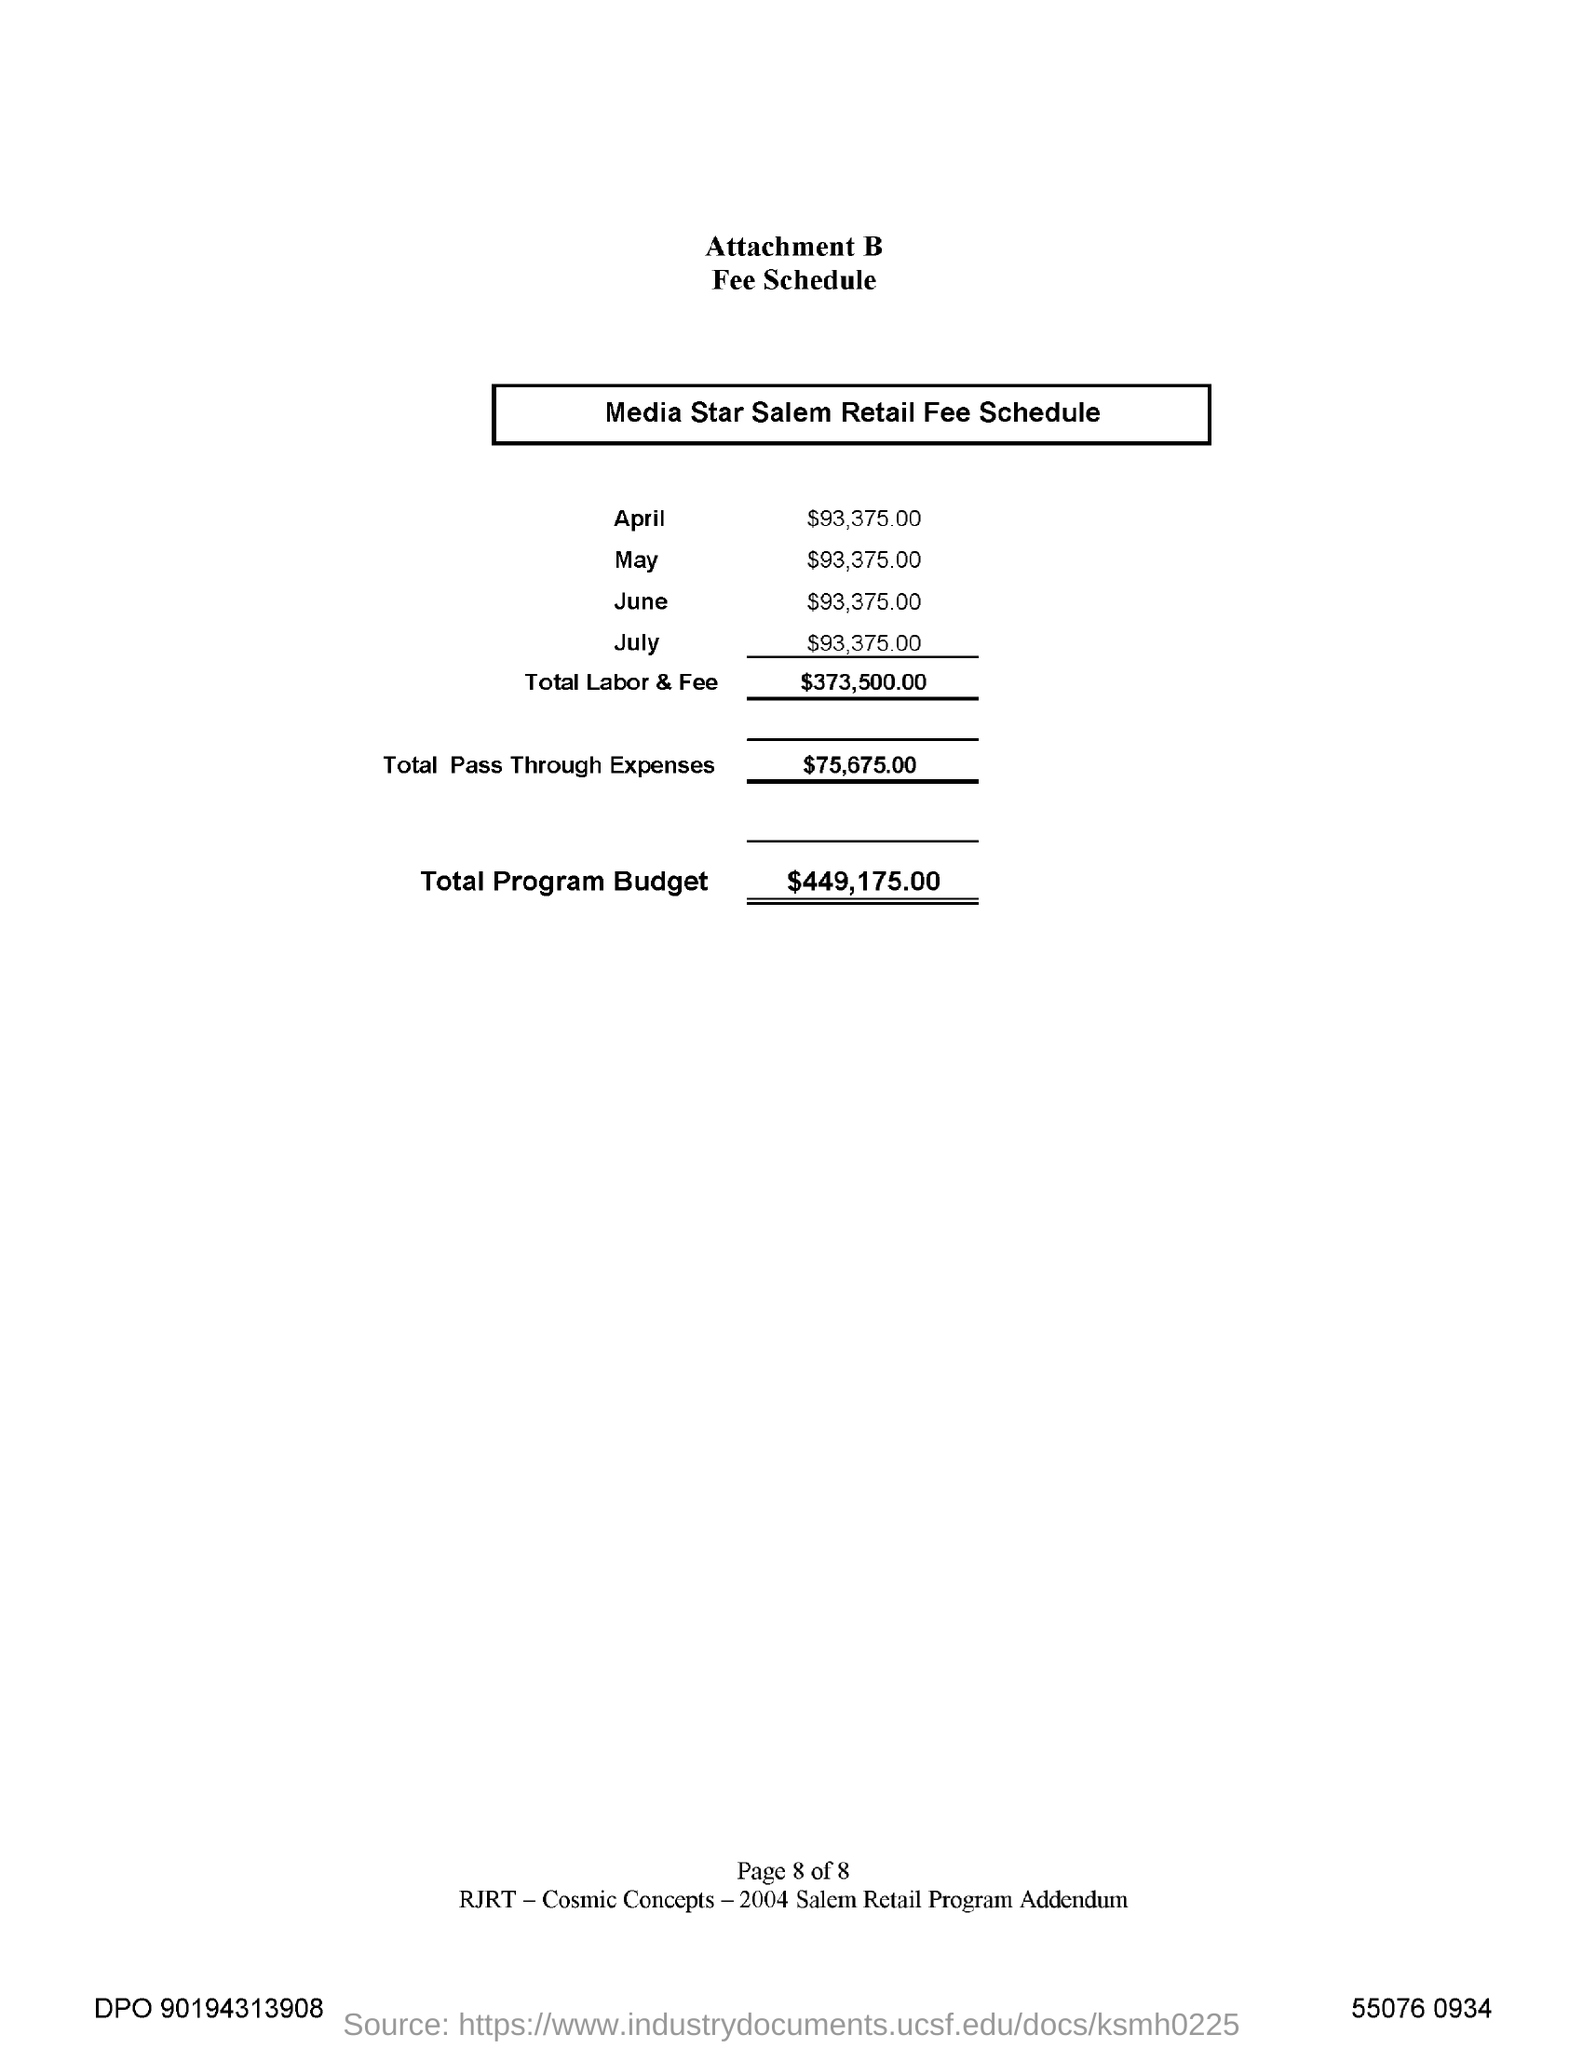Specify some key components in this picture. The total program budget is $449,175.00. The total labor and fee is $373,500.00. 